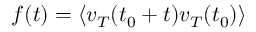Convert formula to latex. <formula><loc_0><loc_0><loc_500><loc_500>f ( t ) = \langle v _ { T } ( t _ { 0 } + t ) v _ { T } ( t _ { 0 } ) \rangle</formula> 